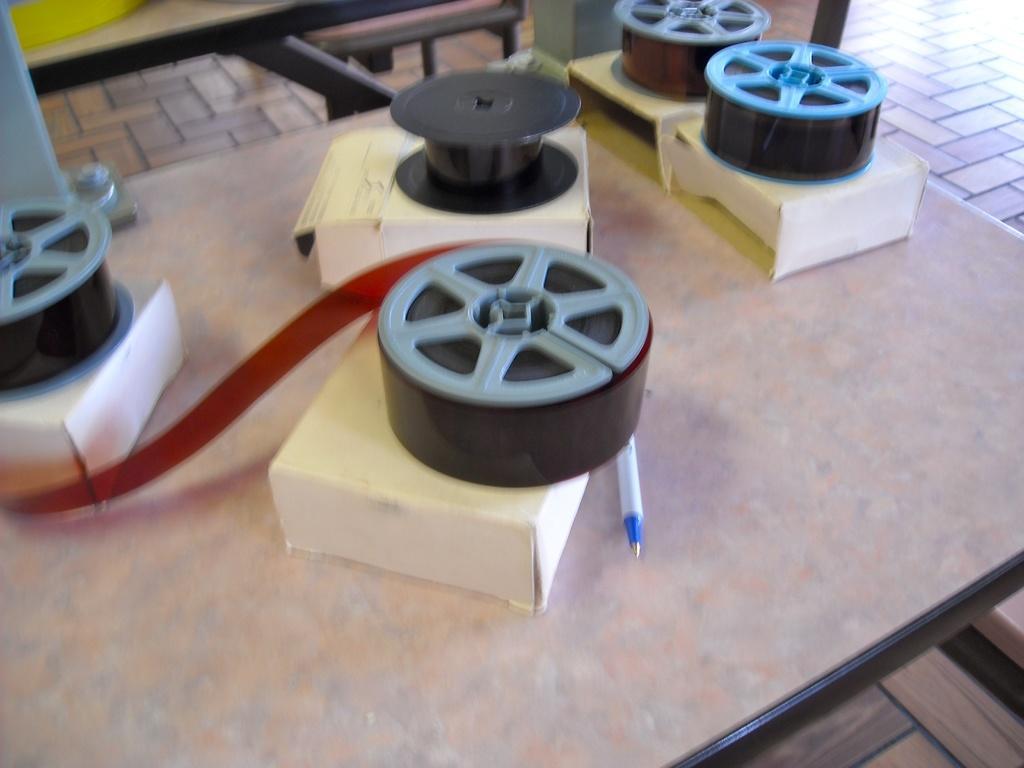Describe this image in one or two sentences. In this image we can see a table and on the table there are satin ribbons, cardboard cartons and a pen. 